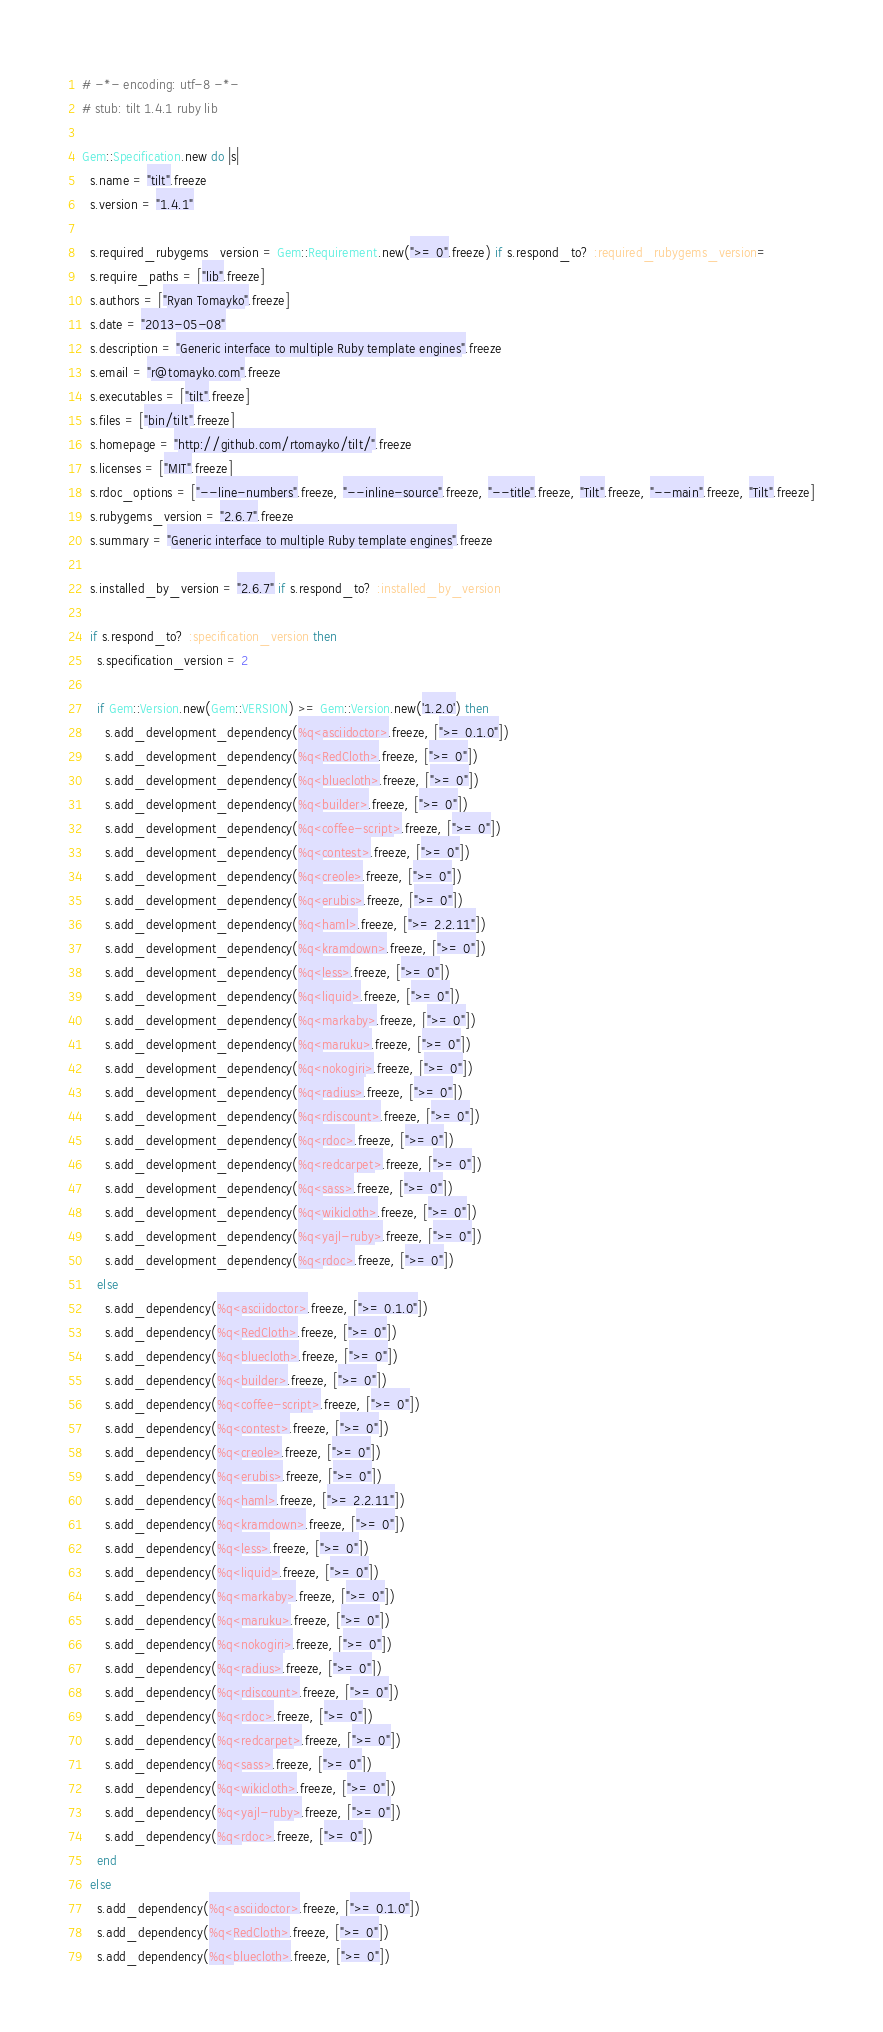Convert code to text. <code><loc_0><loc_0><loc_500><loc_500><_Ruby_># -*- encoding: utf-8 -*-
# stub: tilt 1.4.1 ruby lib

Gem::Specification.new do |s|
  s.name = "tilt".freeze
  s.version = "1.4.1"

  s.required_rubygems_version = Gem::Requirement.new(">= 0".freeze) if s.respond_to? :required_rubygems_version=
  s.require_paths = ["lib".freeze]
  s.authors = ["Ryan Tomayko".freeze]
  s.date = "2013-05-08"
  s.description = "Generic interface to multiple Ruby template engines".freeze
  s.email = "r@tomayko.com".freeze
  s.executables = ["tilt".freeze]
  s.files = ["bin/tilt".freeze]
  s.homepage = "http://github.com/rtomayko/tilt/".freeze
  s.licenses = ["MIT".freeze]
  s.rdoc_options = ["--line-numbers".freeze, "--inline-source".freeze, "--title".freeze, "Tilt".freeze, "--main".freeze, "Tilt".freeze]
  s.rubygems_version = "2.6.7".freeze
  s.summary = "Generic interface to multiple Ruby template engines".freeze

  s.installed_by_version = "2.6.7" if s.respond_to? :installed_by_version

  if s.respond_to? :specification_version then
    s.specification_version = 2

    if Gem::Version.new(Gem::VERSION) >= Gem::Version.new('1.2.0') then
      s.add_development_dependency(%q<asciidoctor>.freeze, [">= 0.1.0"])
      s.add_development_dependency(%q<RedCloth>.freeze, [">= 0"])
      s.add_development_dependency(%q<bluecloth>.freeze, [">= 0"])
      s.add_development_dependency(%q<builder>.freeze, [">= 0"])
      s.add_development_dependency(%q<coffee-script>.freeze, [">= 0"])
      s.add_development_dependency(%q<contest>.freeze, [">= 0"])
      s.add_development_dependency(%q<creole>.freeze, [">= 0"])
      s.add_development_dependency(%q<erubis>.freeze, [">= 0"])
      s.add_development_dependency(%q<haml>.freeze, [">= 2.2.11"])
      s.add_development_dependency(%q<kramdown>.freeze, [">= 0"])
      s.add_development_dependency(%q<less>.freeze, [">= 0"])
      s.add_development_dependency(%q<liquid>.freeze, [">= 0"])
      s.add_development_dependency(%q<markaby>.freeze, [">= 0"])
      s.add_development_dependency(%q<maruku>.freeze, [">= 0"])
      s.add_development_dependency(%q<nokogiri>.freeze, [">= 0"])
      s.add_development_dependency(%q<radius>.freeze, [">= 0"])
      s.add_development_dependency(%q<rdiscount>.freeze, [">= 0"])
      s.add_development_dependency(%q<rdoc>.freeze, [">= 0"])
      s.add_development_dependency(%q<redcarpet>.freeze, [">= 0"])
      s.add_development_dependency(%q<sass>.freeze, [">= 0"])
      s.add_development_dependency(%q<wikicloth>.freeze, [">= 0"])
      s.add_development_dependency(%q<yajl-ruby>.freeze, [">= 0"])
      s.add_development_dependency(%q<rdoc>.freeze, [">= 0"])
    else
      s.add_dependency(%q<asciidoctor>.freeze, [">= 0.1.0"])
      s.add_dependency(%q<RedCloth>.freeze, [">= 0"])
      s.add_dependency(%q<bluecloth>.freeze, [">= 0"])
      s.add_dependency(%q<builder>.freeze, [">= 0"])
      s.add_dependency(%q<coffee-script>.freeze, [">= 0"])
      s.add_dependency(%q<contest>.freeze, [">= 0"])
      s.add_dependency(%q<creole>.freeze, [">= 0"])
      s.add_dependency(%q<erubis>.freeze, [">= 0"])
      s.add_dependency(%q<haml>.freeze, [">= 2.2.11"])
      s.add_dependency(%q<kramdown>.freeze, [">= 0"])
      s.add_dependency(%q<less>.freeze, [">= 0"])
      s.add_dependency(%q<liquid>.freeze, [">= 0"])
      s.add_dependency(%q<markaby>.freeze, [">= 0"])
      s.add_dependency(%q<maruku>.freeze, [">= 0"])
      s.add_dependency(%q<nokogiri>.freeze, [">= 0"])
      s.add_dependency(%q<radius>.freeze, [">= 0"])
      s.add_dependency(%q<rdiscount>.freeze, [">= 0"])
      s.add_dependency(%q<rdoc>.freeze, [">= 0"])
      s.add_dependency(%q<redcarpet>.freeze, [">= 0"])
      s.add_dependency(%q<sass>.freeze, [">= 0"])
      s.add_dependency(%q<wikicloth>.freeze, [">= 0"])
      s.add_dependency(%q<yajl-ruby>.freeze, [">= 0"])
      s.add_dependency(%q<rdoc>.freeze, [">= 0"])
    end
  else
    s.add_dependency(%q<asciidoctor>.freeze, [">= 0.1.0"])
    s.add_dependency(%q<RedCloth>.freeze, [">= 0"])
    s.add_dependency(%q<bluecloth>.freeze, [">= 0"])</code> 